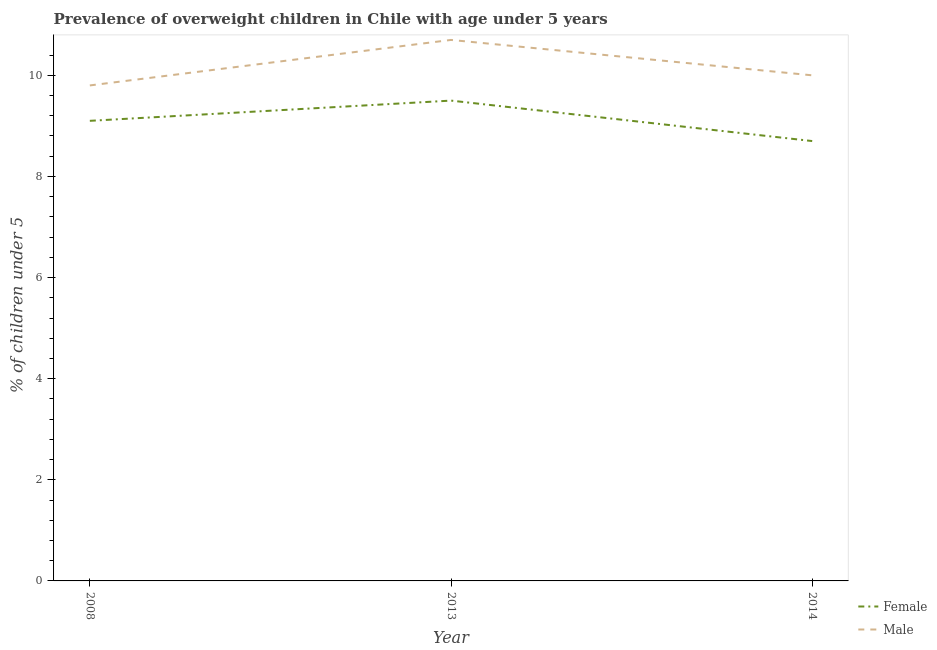Does the line corresponding to percentage of obese male children intersect with the line corresponding to percentage of obese female children?
Your answer should be very brief. No. What is the percentage of obese male children in 2014?
Your answer should be compact. 10. Across all years, what is the maximum percentage of obese male children?
Make the answer very short. 10.7. Across all years, what is the minimum percentage of obese female children?
Your response must be concise. 8.7. What is the total percentage of obese male children in the graph?
Your answer should be compact. 30.5. What is the difference between the percentage of obese male children in 2008 and that in 2014?
Give a very brief answer. -0.2. What is the difference between the percentage of obese male children in 2008 and the percentage of obese female children in 2014?
Provide a succinct answer. 1.1. What is the average percentage of obese female children per year?
Your response must be concise. 9.1. In the year 2013, what is the difference between the percentage of obese female children and percentage of obese male children?
Your response must be concise. -1.2. In how many years, is the percentage of obese female children greater than 4.8 %?
Keep it short and to the point. 3. What is the ratio of the percentage of obese female children in 2008 to that in 2013?
Ensure brevity in your answer.  0.96. Is the difference between the percentage of obese male children in 2008 and 2014 greater than the difference between the percentage of obese female children in 2008 and 2014?
Make the answer very short. No. What is the difference between the highest and the second highest percentage of obese male children?
Keep it short and to the point. 0.7. What is the difference between the highest and the lowest percentage of obese male children?
Give a very brief answer. 0.9. In how many years, is the percentage of obese female children greater than the average percentage of obese female children taken over all years?
Ensure brevity in your answer.  2. Does the percentage of obese female children monotonically increase over the years?
Provide a short and direct response. No. Is the percentage of obese male children strictly greater than the percentage of obese female children over the years?
Make the answer very short. Yes. How many years are there in the graph?
Ensure brevity in your answer.  3. What is the difference between two consecutive major ticks on the Y-axis?
Make the answer very short. 2. Are the values on the major ticks of Y-axis written in scientific E-notation?
Your response must be concise. No. How many legend labels are there?
Offer a very short reply. 2. What is the title of the graph?
Provide a succinct answer. Prevalence of overweight children in Chile with age under 5 years. Does "By country of origin" appear as one of the legend labels in the graph?
Provide a succinct answer. No. What is the label or title of the X-axis?
Offer a very short reply. Year. What is the label or title of the Y-axis?
Provide a short and direct response.  % of children under 5. What is the  % of children under 5 of Female in 2008?
Offer a very short reply. 9.1. What is the  % of children under 5 in Male in 2008?
Your answer should be very brief. 9.8. What is the  % of children under 5 of Male in 2013?
Offer a terse response. 10.7. What is the  % of children under 5 in Female in 2014?
Your answer should be compact. 8.7. Across all years, what is the maximum  % of children under 5 in Male?
Your response must be concise. 10.7. Across all years, what is the minimum  % of children under 5 of Female?
Keep it short and to the point. 8.7. Across all years, what is the minimum  % of children under 5 of Male?
Your response must be concise. 9.8. What is the total  % of children under 5 of Female in the graph?
Ensure brevity in your answer.  27.3. What is the total  % of children under 5 of Male in the graph?
Give a very brief answer. 30.5. What is the difference between the  % of children under 5 of Female in 2008 and that in 2013?
Offer a very short reply. -0.4. What is the difference between the  % of children under 5 in Female in 2013 and that in 2014?
Make the answer very short. 0.8. What is the difference between the  % of children under 5 of Male in 2013 and that in 2014?
Your answer should be compact. 0.7. What is the difference between the  % of children under 5 of Female in 2008 and the  % of children under 5 of Male in 2013?
Keep it short and to the point. -1.6. What is the difference between the  % of children under 5 in Female in 2008 and the  % of children under 5 in Male in 2014?
Offer a terse response. -0.9. What is the difference between the  % of children under 5 in Female in 2013 and the  % of children under 5 in Male in 2014?
Provide a succinct answer. -0.5. What is the average  % of children under 5 in Female per year?
Keep it short and to the point. 9.1. What is the average  % of children under 5 in Male per year?
Keep it short and to the point. 10.17. In the year 2008, what is the difference between the  % of children under 5 in Female and  % of children under 5 in Male?
Give a very brief answer. -0.7. In the year 2013, what is the difference between the  % of children under 5 in Female and  % of children under 5 in Male?
Your response must be concise. -1.2. In the year 2014, what is the difference between the  % of children under 5 of Female and  % of children under 5 of Male?
Give a very brief answer. -1.3. What is the ratio of the  % of children under 5 in Female in 2008 to that in 2013?
Offer a very short reply. 0.96. What is the ratio of the  % of children under 5 in Male in 2008 to that in 2013?
Keep it short and to the point. 0.92. What is the ratio of the  % of children under 5 in Female in 2008 to that in 2014?
Ensure brevity in your answer.  1.05. What is the ratio of the  % of children under 5 in Male in 2008 to that in 2014?
Keep it short and to the point. 0.98. What is the ratio of the  % of children under 5 of Female in 2013 to that in 2014?
Your answer should be very brief. 1.09. What is the ratio of the  % of children under 5 of Male in 2013 to that in 2014?
Provide a succinct answer. 1.07. What is the difference between the highest and the second highest  % of children under 5 in Male?
Provide a short and direct response. 0.7. 